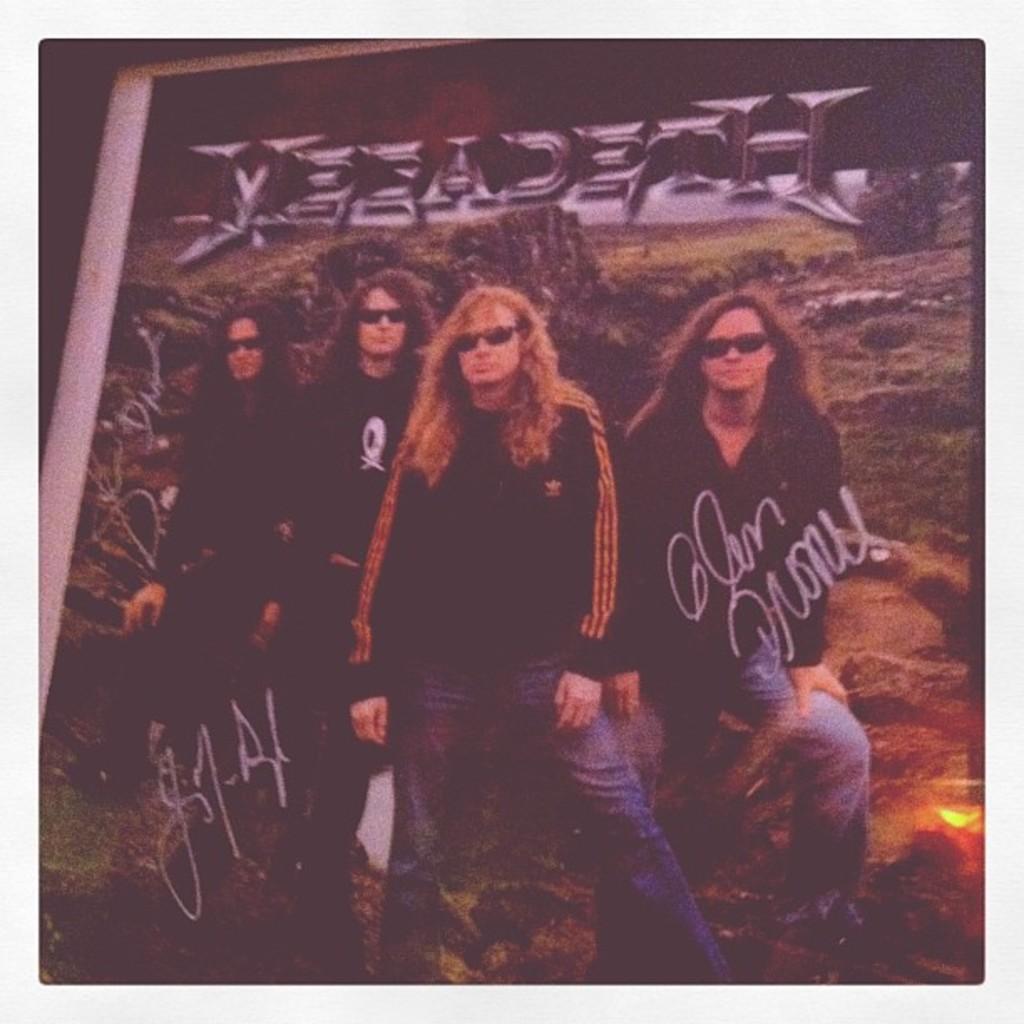In one or two sentences, can you explain what this image depicts? This is the image of a photograph as we can see there are four persons standing in middle of this image and there is some text written at top of this image. 